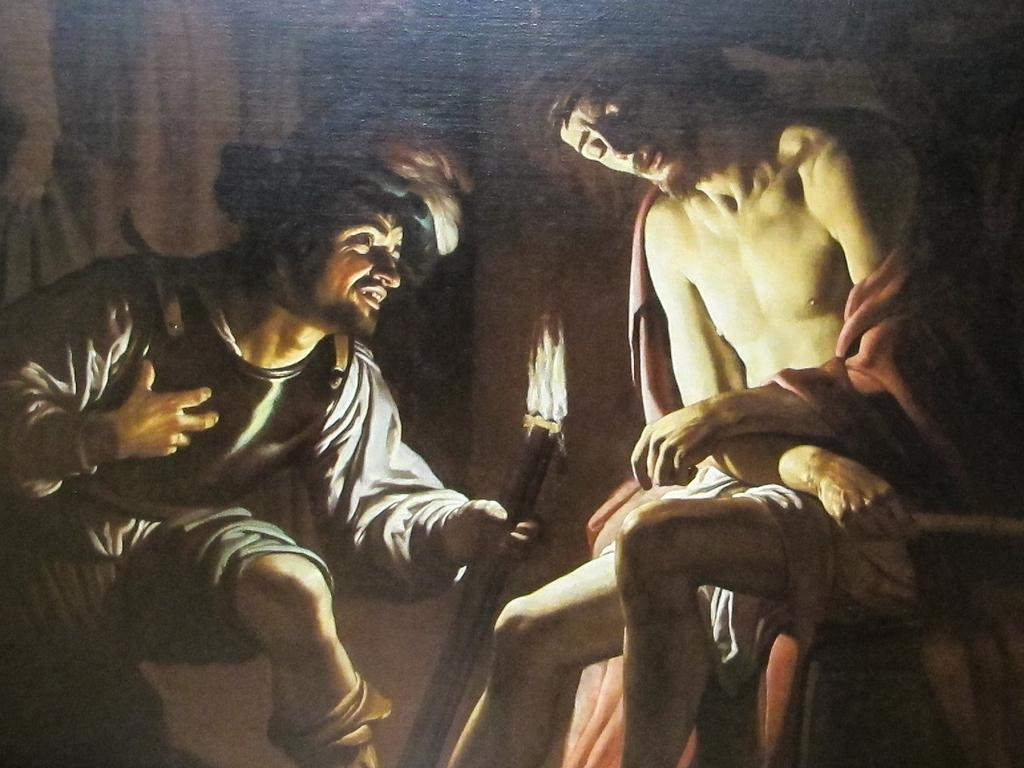What type of artwork is depicted in the image? The image is a painting. Can you describe the people in the painting? There is a man sitting in the painting, and another person is holding a torch with fire. What might the person holding the torch be doing? The person holding the torch might be providing light or signaling in the painting. What type of quiver is the man using in the painting? There is no quiver present in the painting; the man is simply sitting. 